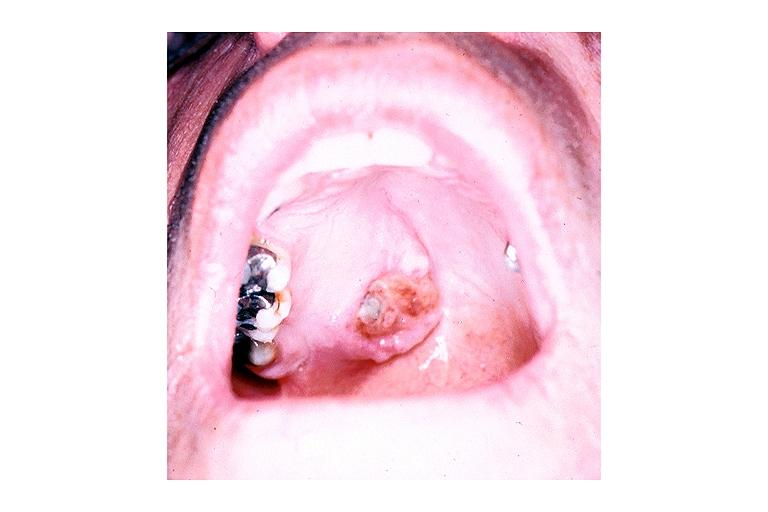s oral present?
Answer the question using a single word or phrase. Yes 